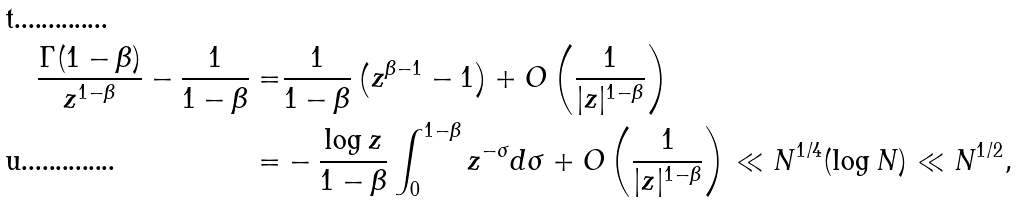<formula> <loc_0><loc_0><loc_500><loc_500>\frac { \Gamma ( 1 - \beta ) } { z ^ { 1 - \beta } } - \frac { 1 } { 1 - \beta } = & \frac { 1 } { 1 - \beta } \left ( z ^ { \beta - 1 } - 1 \right ) + O \left ( \frac { 1 } { | z | ^ { 1 - \beta } } \right ) \\ = & - \frac { \log z } { 1 - \beta } \int _ { 0 } ^ { 1 - \beta } z ^ { - \sigma } d \sigma + O \left ( \frac { 1 } { | z | ^ { 1 - \beta } } \right ) \ll N ^ { 1 / 4 } ( \log N ) \ll N ^ { 1 / 2 } ,</formula> 